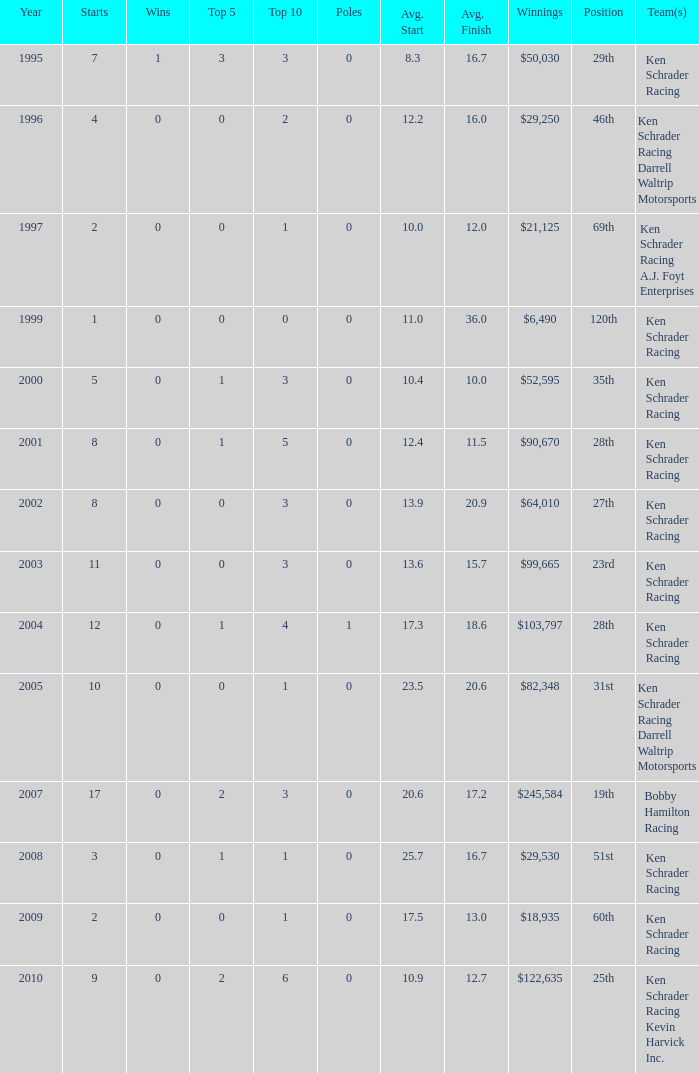7? 0.0. 